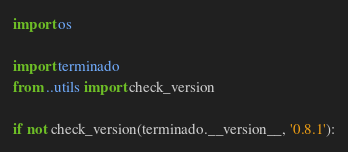<code> <loc_0><loc_0><loc_500><loc_500><_Python_>import os

import terminado
from ..utils import check_version

if not check_version(terminado.__version__, '0.8.1'):</code> 